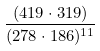Convert formula to latex. <formula><loc_0><loc_0><loc_500><loc_500>\frac { ( 4 1 9 \cdot 3 1 9 ) } { ( 2 7 8 \cdot 1 8 6 ) ^ { 1 1 } }</formula> 